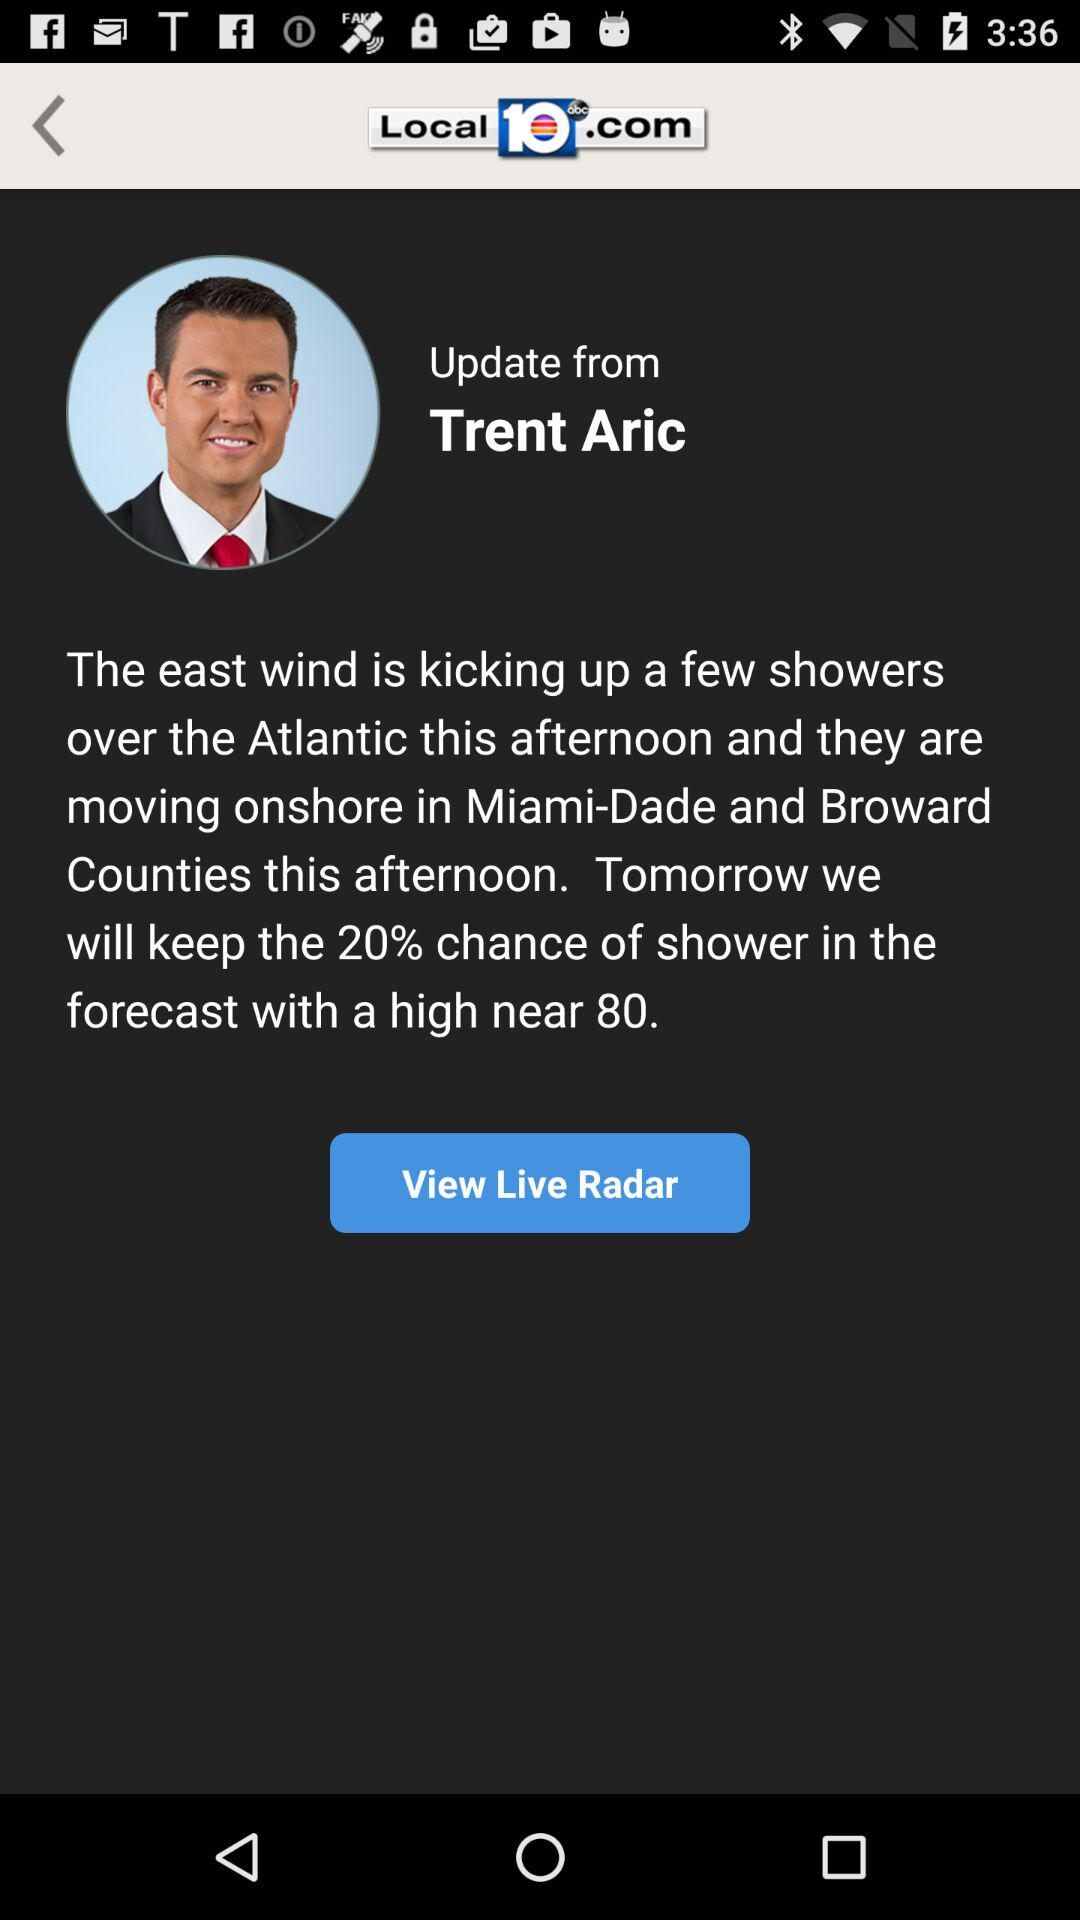What is the country's name where Trent Aric is moving?
When the provided information is insufficient, respond with <no answer>. <no answer> 